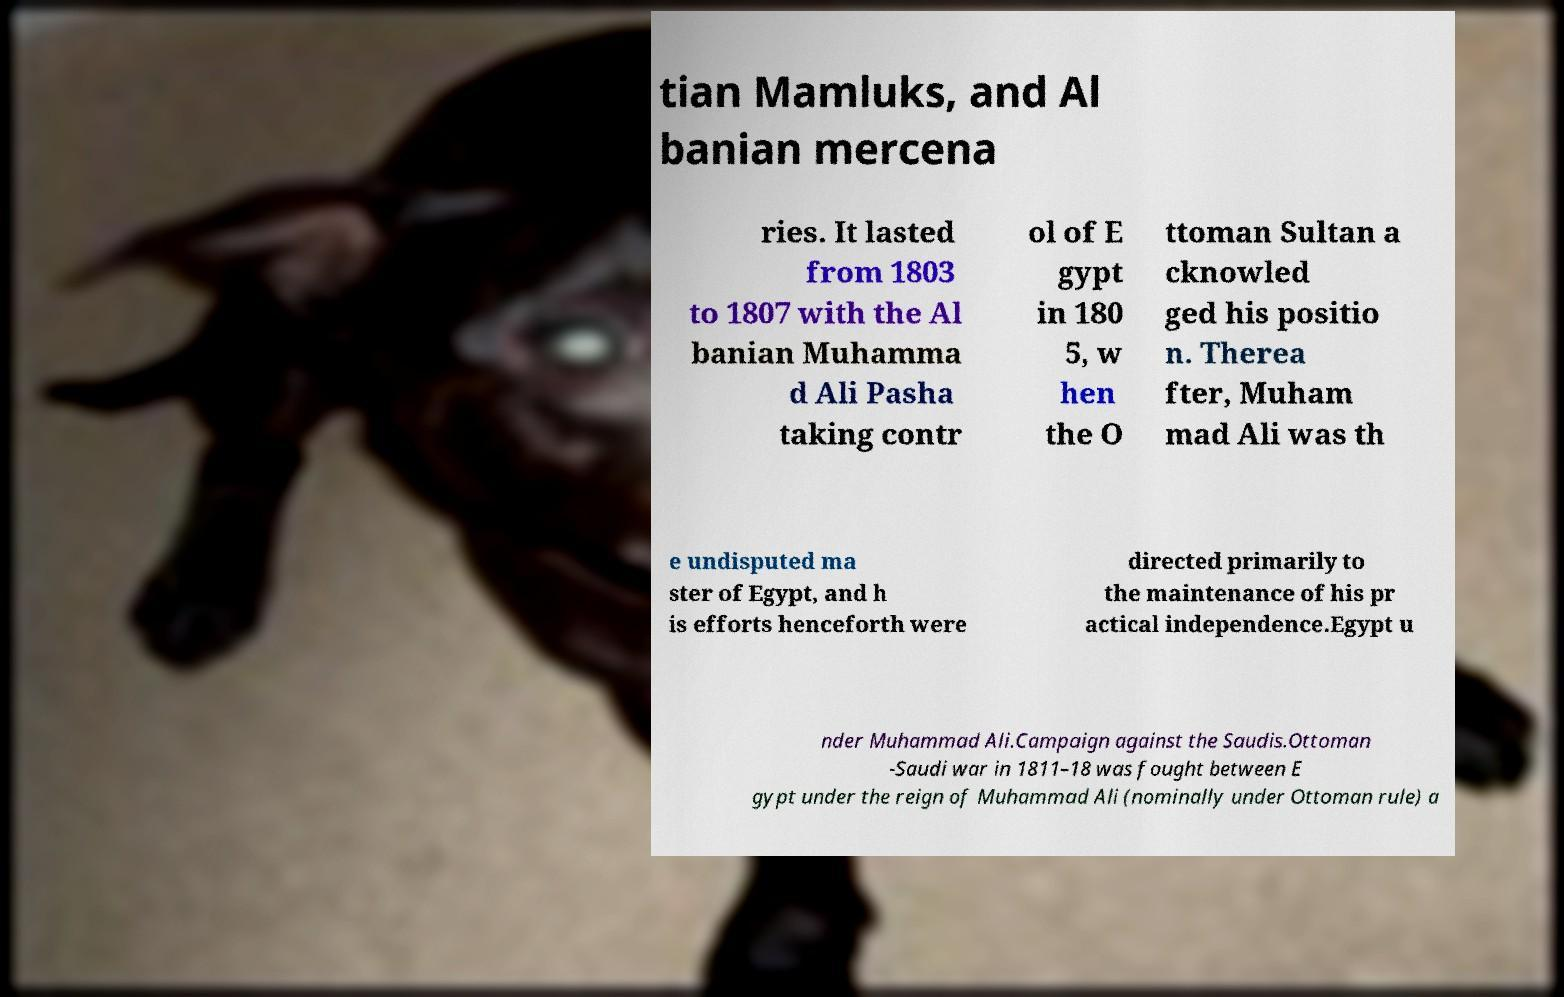Could you assist in decoding the text presented in this image and type it out clearly? tian Mamluks, and Al banian mercena ries. It lasted from 1803 to 1807 with the Al banian Muhamma d Ali Pasha taking contr ol of E gypt in 180 5, w hen the O ttoman Sultan a cknowled ged his positio n. Therea fter, Muham mad Ali was th e undisputed ma ster of Egypt, and h is efforts henceforth were directed primarily to the maintenance of his pr actical independence.Egypt u nder Muhammad Ali.Campaign against the Saudis.Ottoman -Saudi war in 1811–18 was fought between E gypt under the reign of Muhammad Ali (nominally under Ottoman rule) a 